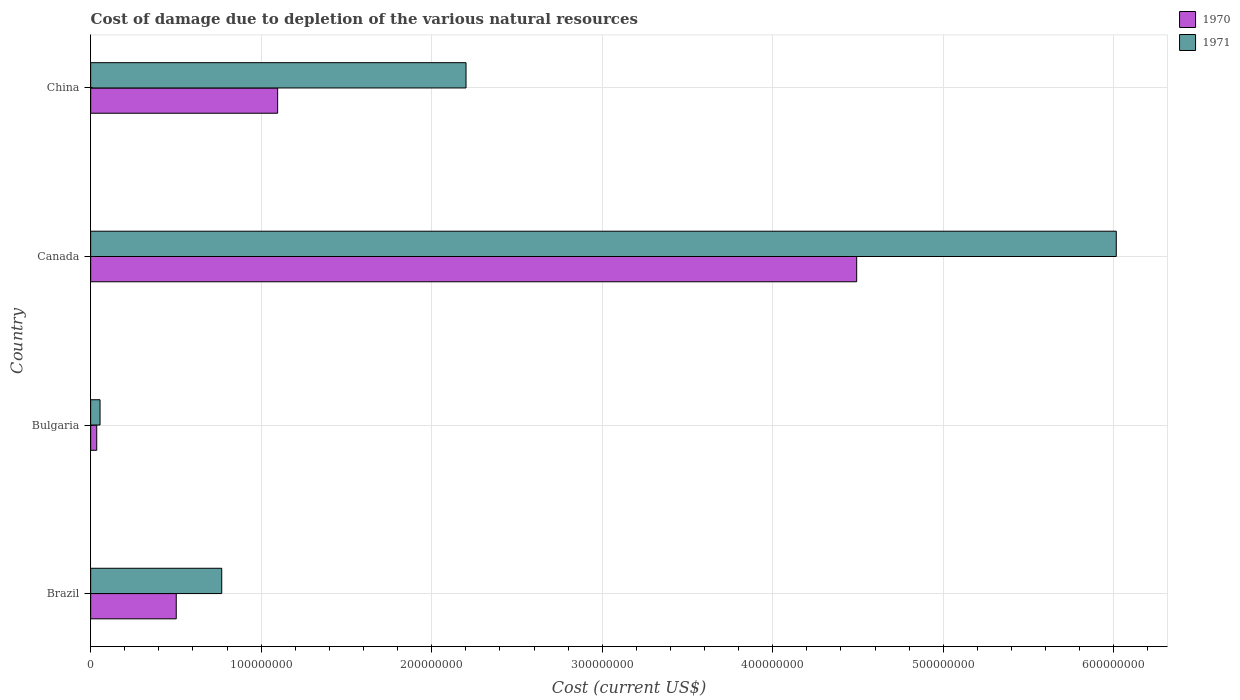How many different coloured bars are there?
Your answer should be very brief. 2. How many groups of bars are there?
Provide a succinct answer. 4. Are the number of bars per tick equal to the number of legend labels?
Your response must be concise. Yes. How many bars are there on the 2nd tick from the top?
Give a very brief answer. 2. How many bars are there on the 4th tick from the bottom?
Offer a very short reply. 2. What is the label of the 4th group of bars from the top?
Give a very brief answer. Brazil. What is the cost of damage caused due to the depletion of various natural resources in 1971 in China?
Offer a very short reply. 2.20e+08. Across all countries, what is the maximum cost of damage caused due to the depletion of various natural resources in 1970?
Your answer should be compact. 4.49e+08. Across all countries, what is the minimum cost of damage caused due to the depletion of various natural resources in 1970?
Offer a terse response. 3.56e+06. In which country was the cost of damage caused due to the depletion of various natural resources in 1970 maximum?
Offer a terse response. Canada. In which country was the cost of damage caused due to the depletion of various natural resources in 1970 minimum?
Your response must be concise. Bulgaria. What is the total cost of damage caused due to the depletion of various natural resources in 1970 in the graph?
Provide a short and direct response. 6.13e+08. What is the difference between the cost of damage caused due to the depletion of various natural resources in 1970 in Brazil and that in Bulgaria?
Your answer should be compact. 4.66e+07. What is the difference between the cost of damage caused due to the depletion of various natural resources in 1971 in Bulgaria and the cost of damage caused due to the depletion of various natural resources in 1970 in Brazil?
Ensure brevity in your answer.  -4.47e+07. What is the average cost of damage caused due to the depletion of various natural resources in 1971 per country?
Your answer should be very brief. 2.26e+08. What is the difference between the cost of damage caused due to the depletion of various natural resources in 1970 and cost of damage caused due to the depletion of various natural resources in 1971 in China?
Ensure brevity in your answer.  -1.10e+08. In how many countries, is the cost of damage caused due to the depletion of various natural resources in 1970 greater than 40000000 US$?
Your response must be concise. 3. What is the ratio of the cost of damage caused due to the depletion of various natural resources in 1970 in Canada to that in China?
Provide a succinct answer. 4.1. Is the difference between the cost of damage caused due to the depletion of various natural resources in 1970 in Canada and China greater than the difference between the cost of damage caused due to the depletion of various natural resources in 1971 in Canada and China?
Your answer should be compact. No. What is the difference between the highest and the second highest cost of damage caused due to the depletion of various natural resources in 1970?
Give a very brief answer. 3.40e+08. What is the difference between the highest and the lowest cost of damage caused due to the depletion of various natural resources in 1971?
Offer a terse response. 5.96e+08. In how many countries, is the cost of damage caused due to the depletion of various natural resources in 1971 greater than the average cost of damage caused due to the depletion of various natural resources in 1971 taken over all countries?
Provide a short and direct response. 1. How many bars are there?
Ensure brevity in your answer.  8. What is the difference between two consecutive major ticks on the X-axis?
Give a very brief answer. 1.00e+08. Does the graph contain any zero values?
Provide a succinct answer. No. Does the graph contain grids?
Give a very brief answer. Yes. Where does the legend appear in the graph?
Provide a short and direct response. Top right. How are the legend labels stacked?
Your answer should be compact. Vertical. What is the title of the graph?
Keep it short and to the point. Cost of damage due to depletion of the various natural resources. Does "1996" appear as one of the legend labels in the graph?
Keep it short and to the point. No. What is the label or title of the X-axis?
Offer a very short reply. Cost (current US$). What is the label or title of the Y-axis?
Provide a succinct answer. Country. What is the Cost (current US$) of 1970 in Brazil?
Provide a short and direct response. 5.02e+07. What is the Cost (current US$) in 1971 in Brazil?
Provide a succinct answer. 7.69e+07. What is the Cost (current US$) of 1970 in Bulgaria?
Make the answer very short. 3.56e+06. What is the Cost (current US$) of 1971 in Bulgaria?
Make the answer very short. 5.51e+06. What is the Cost (current US$) in 1970 in Canada?
Keep it short and to the point. 4.49e+08. What is the Cost (current US$) of 1971 in Canada?
Keep it short and to the point. 6.01e+08. What is the Cost (current US$) of 1970 in China?
Your answer should be very brief. 1.10e+08. What is the Cost (current US$) of 1971 in China?
Give a very brief answer. 2.20e+08. Across all countries, what is the maximum Cost (current US$) of 1970?
Provide a short and direct response. 4.49e+08. Across all countries, what is the maximum Cost (current US$) of 1971?
Ensure brevity in your answer.  6.01e+08. Across all countries, what is the minimum Cost (current US$) of 1970?
Keep it short and to the point. 3.56e+06. Across all countries, what is the minimum Cost (current US$) of 1971?
Your answer should be compact. 5.51e+06. What is the total Cost (current US$) in 1970 in the graph?
Ensure brevity in your answer.  6.13e+08. What is the total Cost (current US$) in 1971 in the graph?
Your answer should be compact. 9.04e+08. What is the difference between the Cost (current US$) in 1970 in Brazil and that in Bulgaria?
Give a very brief answer. 4.66e+07. What is the difference between the Cost (current US$) in 1971 in Brazil and that in Bulgaria?
Give a very brief answer. 7.14e+07. What is the difference between the Cost (current US$) in 1970 in Brazil and that in Canada?
Keep it short and to the point. -3.99e+08. What is the difference between the Cost (current US$) of 1971 in Brazil and that in Canada?
Your answer should be compact. -5.25e+08. What is the difference between the Cost (current US$) of 1970 in Brazil and that in China?
Ensure brevity in your answer.  -5.95e+07. What is the difference between the Cost (current US$) of 1971 in Brazil and that in China?
Provide a short and direct response. -1.43e+08. What is the difference between the Cost (current US$) in 1970 in Bulgaria and that in Canada?
Offer a terse response. -4.46e+08. What is the difference between the Cost (current US$) of 1971 in Bulgaria and that in Canada?
Your answer should be compact. -5.96e+08. What is the difference between the Cost (current US$) of 1970 in Bulgaria and that in China?
Keep it short and to the point. -1.06e+08. What is the difference between the Cost (current US$) in 1971 in Bulgaria and that in China?
Your response must be concise. -2.15e+08. What is the difference between the Cost (current US$) of 1970 in Canada and that in China?
Your answer should be compact. 3.40e+08. What is the difference between the Cost (current US$) in 1971 in Canada and that in China?
Keep it short and to the point. 3.81e+08. What is the difference between the Cost (current US$) of 1970 in Brazil and the Cost (current US$) of 1971 in Bulgaria?
Provide a succinct answer. 4.47e+07. What is the difference between the Cost (current US$) in 1970 in Brazil and the Cost (current US$) in 1971 in Canada?
Your response must be concise. -5.51e+08. What is the difference between the Cost (current US$) in 1970 in Brazil and the Cost (current US$) in 1971 in China?
Give a very brief answer. -1.70e+08. What is the difference between the Cost (current US$) in 1970 in Bulgaria and the Cost (current US$) in 1971 in Canada?
Offer a very short reply. -5.98e+08. What is the difference between the Cost (current US$) of 1970 in Bulgaria and the Cost (current US$) of 1971 in China?
Give a very brief answer. -2.17e+08. What is the difference between the Cost (current US$) of 1970 in Canada and the Cost (current US$) of 1971 in China?
Ensure brevity in your answer.  2.29e+08. What is the average Cost (current US$) of 1970 per country?
Keep it short and to the point. 1.53e+08. What is the average Cost (current US$) in 1971 per country?
Provide a succinct answer. 2.26e+08. What is the difference between the Cost (current US$) in 1970 and Cost (current US$) in 1971 in Brazil?
Your answer should be compact. -2.67e+07. What is the difference between the Cost (current US$) of 1970 and Cost (current US$) of 1971 in Bulgaria?
Your answer should be compact. -1.95e+06. What is the difference between the Cost (current US$) in 1970 and Cost (current US$) in 1971 in Canada?
Provide a short and direct response. -1.52e+08. What is the difference between the Cost (current US$) in 1970 and Cost (current US$) in 1971 in China?
Offer a very short reply. -1.10e+08. What is the ratio of the Cost (current US$) of 1970 in Brazil to that in Bulgaria?
Your answer should be very brief. 14.09. What is the ratio of the Cost (current US$) in 1971 in Brazil to that in Bulgaria?
Offer a terse response. 13.95. What is the ratio of the Cost (current US$) of 1970 in Brazil to that in Canada?
Provide a succinct answer. 0.11. What is the ratio of the Cost (current US$) in 1971 in Brazil to that in Canada?
Your answer should be very brief. 0.13. What is the ratio of the Cost (current US$) in 1970 in Brazil to that in China?
Offer a terse response. 0.46. What is the ratio of the Cost (current US$) in 1971 in Brazil to that in China?
Keep it short and to the point. 0.35. What is the ratio of the Cost (current US$) in 1970 in Bulgaria to that in Canada?
Offer a very short reply. 0.01. What is the ratio of the Cost (current US$) of 1971 in Bulgaria to that in Canada?
Keep it short and to the point. 0.01. What is the ratio of the Cost (current US$) in 1970 in Bulgaria to that in China?
Offer a very short reply. 0.03. What is the ratio of the Cost (current US$) in 1971 in Bulgaria to that in China?
Ensure brevity in your answer.  0.03. What is the ratio of the Cost (current US$) of 1970 in Canada to that in China?
Ensure brevity in your answer.  4.1. What is the ratio of the Cost (current US$) in 1971 in Canada to that in China?
Your answer should be very brief. 2.73. What is the difference between the highest and the second highest Cost (current US$) in 1970?
Ensure brevity in your answer.  3.40e+08. What is the difference between the highest and the second highest Cost (current US$) of 1971?
Offer a very short reply. 3.81e+08. What is the difference between the highest and the lowest Cost (current US$) in 1970?
Your answer should be very brief. 4.46e+08. What is the difference between the highest and the lowest Cost (current US$) of 1971?
Ensure brevity in your answer.  5.96e+08. 